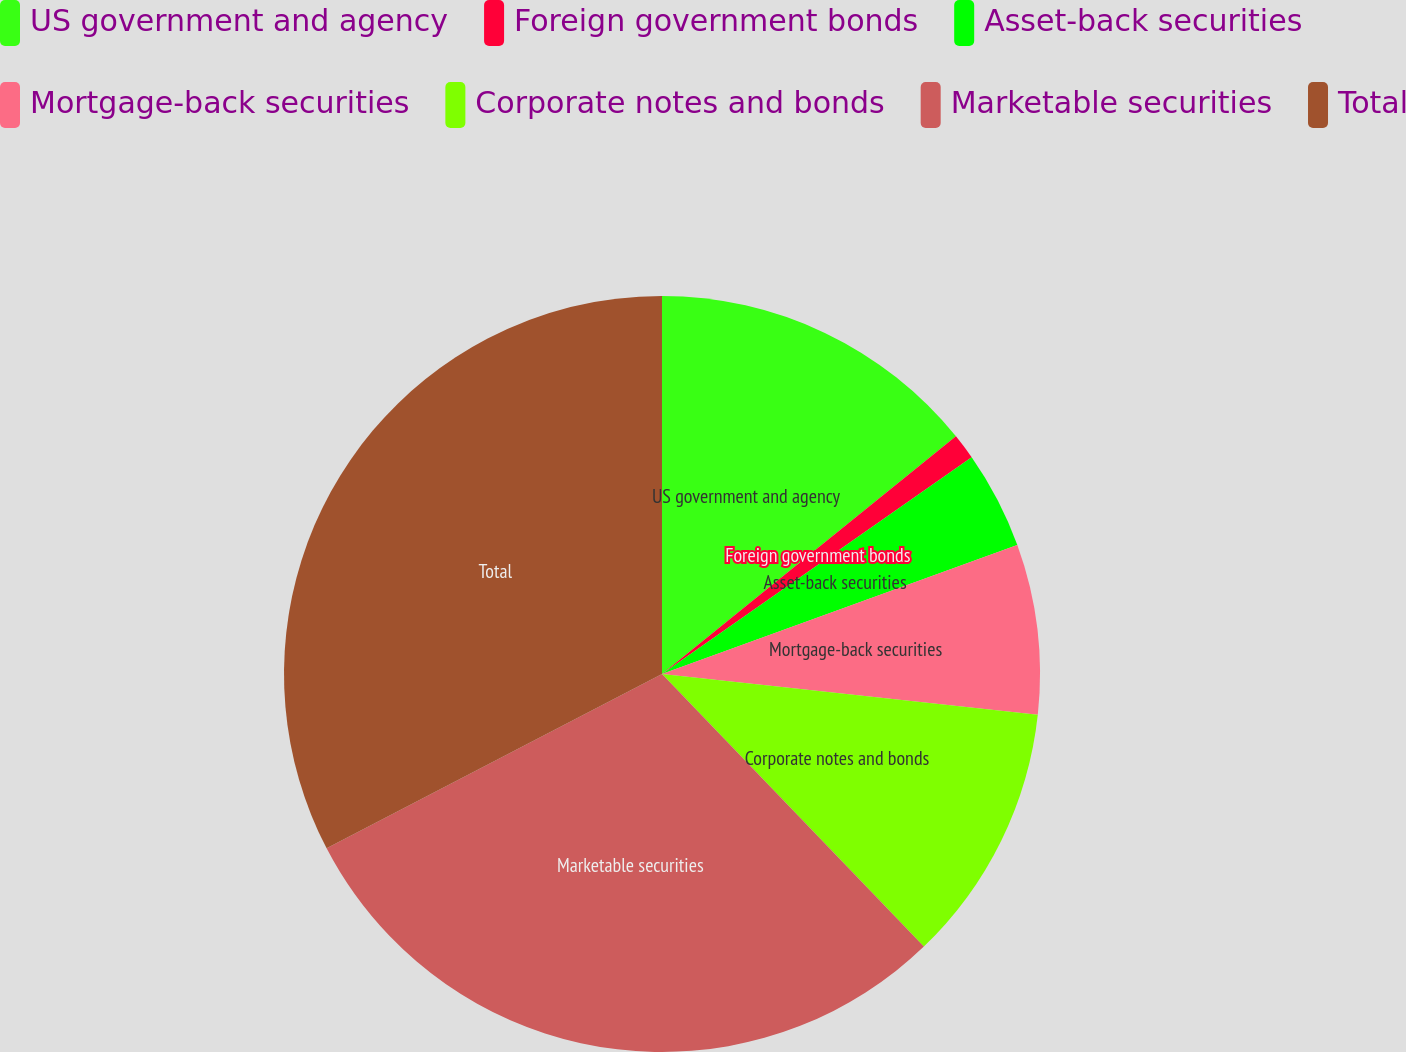<chart> <loc_0><loc_0><loc_500><loc_500><pie_chart><fcel>US government and agency<fcel>Foreign government bonds<fcel>Asset-back securities<fcel>Mortgage-back securities<fcel>Corporate notes and bonds<fcel>Marketable securities<fcel>Total<nl><fcel>14.18%<fcel>1.1%<fcel>4.18%<fcel>7.26%<fcel>11.1%<fcel>29.55%<fcel>32.63%<nl></chart> 